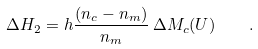Convert formula to latex. <formula><loc_0><loc_0><loc_500><loc_500>\Delta H _ { 2 } = h \frac { ( n _ { c } - n _ { m } ) } { n _ { m } } \, \Delta M _ { c } ( U ) \quad .</formula> 